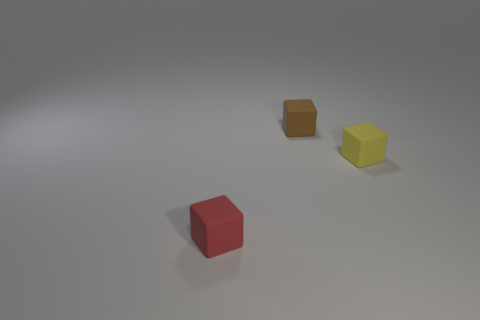Subtract all small yellow blocks. How many blocks are left? 2 Add 2 brown blocks. How many objects exist? 5 Subtract all brown cubes. How many cubes are left? 2 Subtract 0 green balls. How many objects are left? 3 Subtract 2 blocks. How many blocks are left? 1 Subtract all yellow blocks. Subtract all green spheres. How many blocks are left? 2 Subtract all small objects. Subtract all brown cylinders. How many objects are left? 0 Add 3 tiny red matte cubes. How many tiny red matte cubes are left? 4 Add 3 small yellow things. How many small yellow things exist? 4 